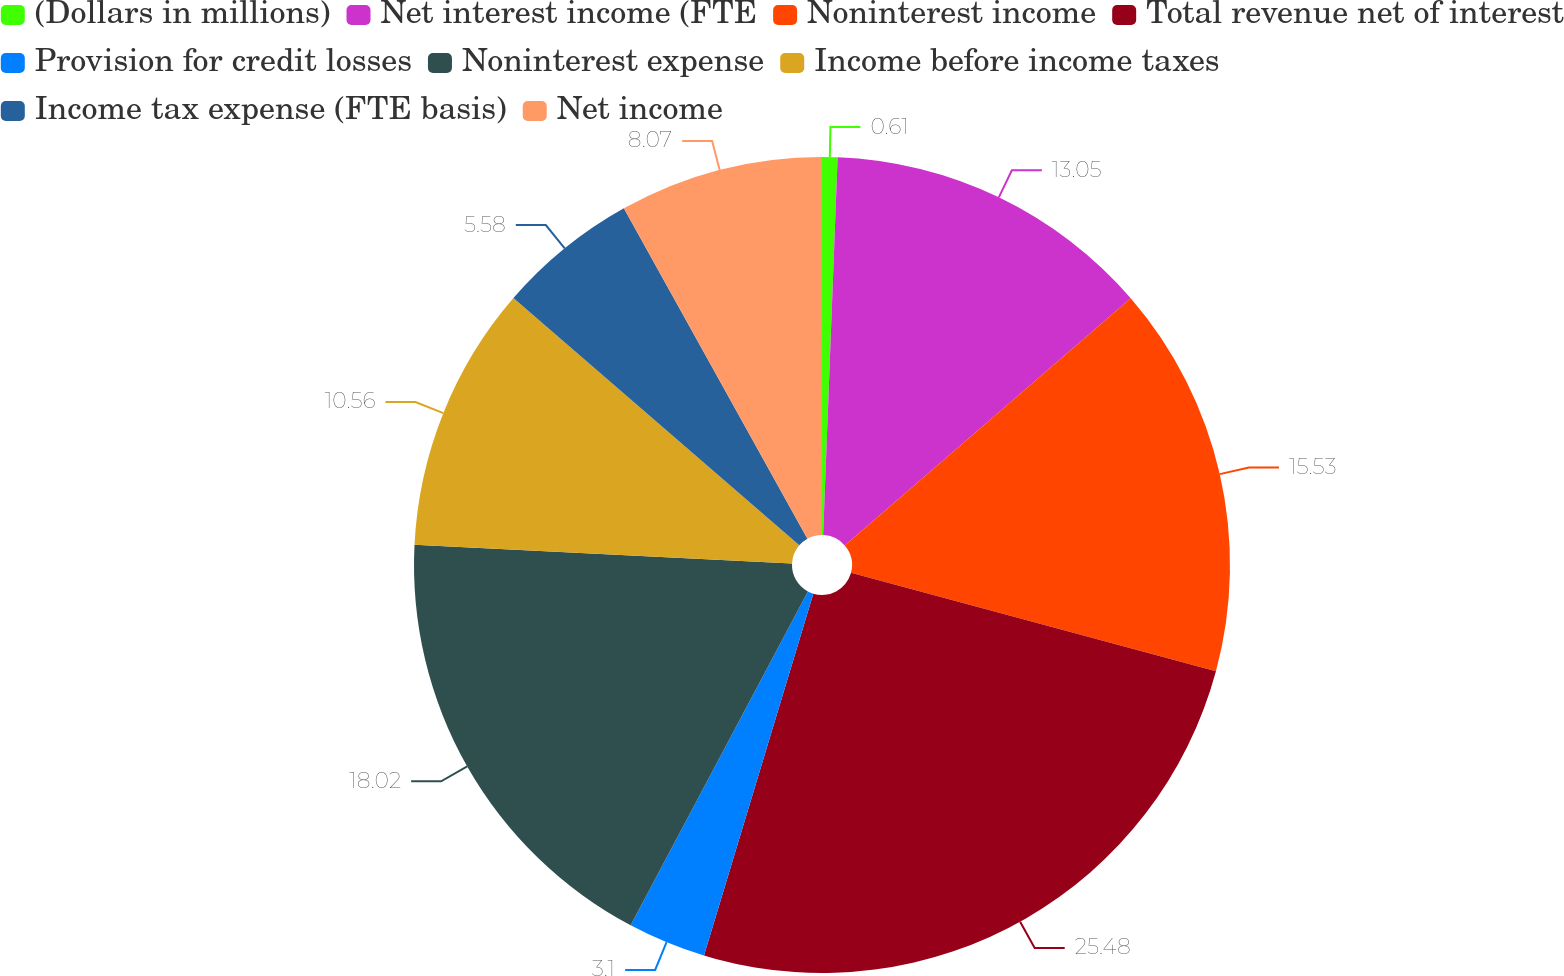Convert chart to OTSL. <chart><loc_0><loc_0><loc_500><loc_500><pie_chart><fcel>(Dollars in millions)<fcel>Net interest income (FTE<fcel>Noninterest income<fcel>Total revenue net of interest<fcel>Provision for credit losses<fcel>Noninterest expense<fcel>Income before income taxes<fcel>Income tax expense (FTE basis)<fcel>Net income<nl><fcel>0.61%<fcel>13.05%<fcel>15.53%<fcel>25.48%<fcel>3.1%<fcel>18.02%<fcel>10.56%<fcel>5.58%<fcel>8.07%<nl></chart> 